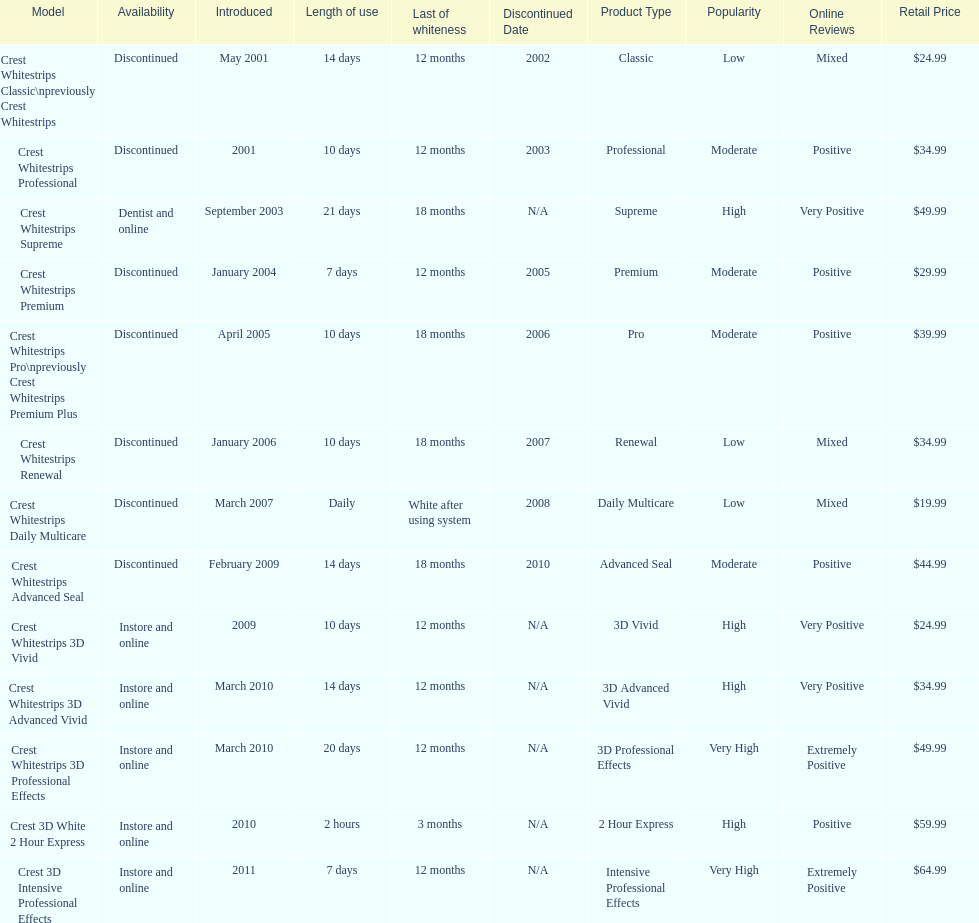Is each white strip discontinued? No. 